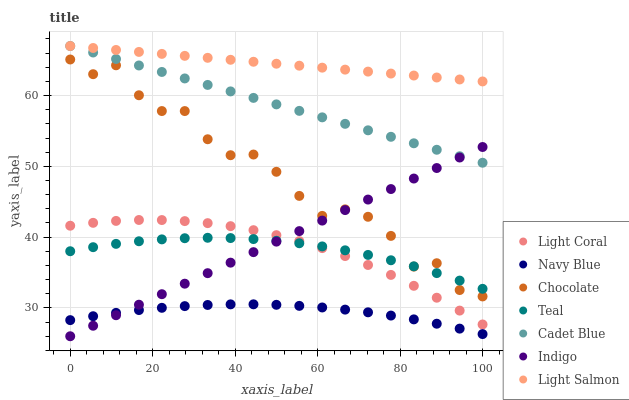Does Navy Blue have the minimum area under the curve?
Answer yes or no. Yes. Does Light Salmon have the maximum area under the curve?
Answer yes or no. Yes. Does Cadet Blue have the minimum area under the curve?
Answer yes or no. No. Does Cadet Blue have the maximum area under the curve?
Answer yes or no. No. Is Indigo the smoothest?
Answer yes or no. Yes. Is Chocolate the roughest?
Answer yes or no. Yes. Is Cadet Blue the smoothest?
Answer yes or no. No. Is Cadet Blue the roughest?
Answer yes or no. No. Does Indigo have the lowest value?
Answer yes or no. Yes. Does Cadet Blue have the lowest value?
Answer yes or no. No. Does Cadet Blue have the highest value?
Answer yes or no. Yes. Does Indigo have the highest value?
Answer yes or no. No. Is Navy Blue less than Light Salmon?
Answer yes or no. Yes. Is Teal greater than Navy Blue?
Answer yes or no. Yes. Does Light Coral intersect Teal?
Answer yes or no. Yes. Is Light Coral less than Teal?
Answer yes or no. No. Is Light Coral greater than Teal?
Answer yes or no. No. Does Navy Blue intersect Light Salmon?
Answer yes or no. No. 